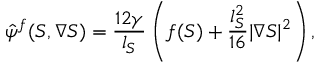Convert formula to latex. <formula><loc_0><loc_0><loc_500><loc_500>\hat { \psi } ^ { f } ( S , \nabla { S } ) = \frac { 1 2 \gamma } { l _ { S } } \left ( f ( S ) + \frac { l _ { S } ^ { 2 } } { 1 6 } | \nabla { S } | ^ { 2 } \right ) ,</formula> 